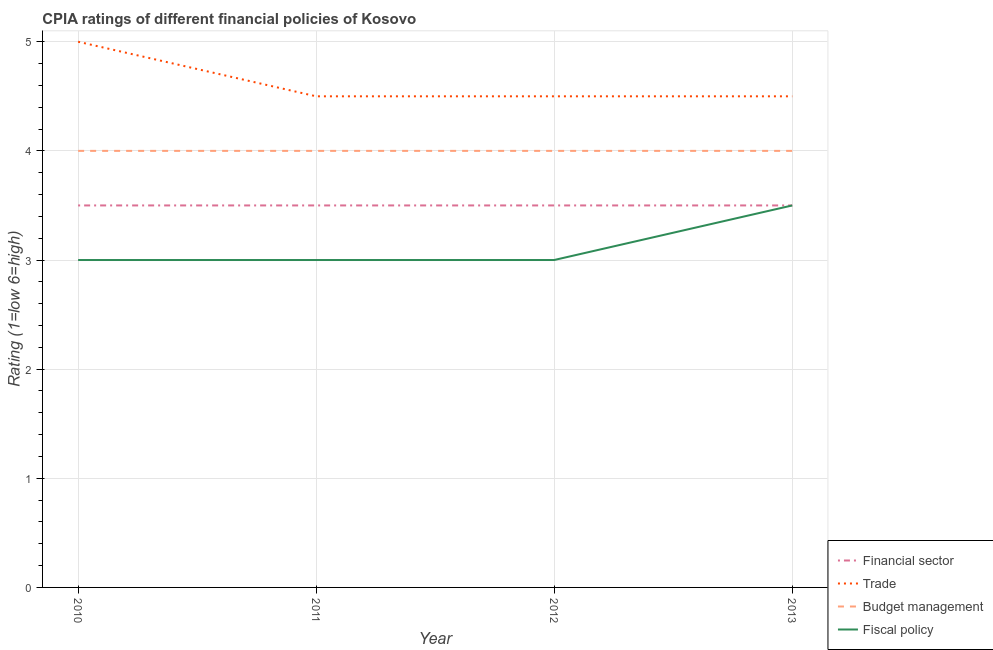Does the line corresponding to cpia rating of budget management intersect with the line corresponding to cpia rating of fiscal policy?
Keep it short and to the point. No. Is the number of lines equal to the number of legend labels?
Give a very brief answer. Yes. Across all years, what is the maximum cpia rating of trade?
Your response must be concise. 5. What is the total cpia rating of fiscal policy in the graph?
Offer a very short reply. 12.5. What is the average cpia rating of financial sector per year?
Provide a short and direct response. 3.5. In how many years, is the cpia rating of trade greater than 2.2?
Ensure brevity in your answer.  4. What is the ratio of the cpia rating of financial sector in 2010 to that in 2011?
Keep it short and to the point. 1. What is the difference between the highest and the second highest cpia rating of fiscal policy?
Your answer should be very brief. 0.5. What is the difference between the highest and the lowest cpia rating of financial sector?
Your answer should be very brief. 0. In how many years, is the cpia rating of trade greater than the average cpia rating of trade taken over all years?
Offer a terse response. 1. Is the sum of the cpia rating of financial sector in 2012 and 2013 greater than the maximum cpia rating of trade across all years?
Provide a short and direct response. Yes. Is it the case that in every year, the sum of the cpia rating of financial sector and cpia rating of trade is greater than the cpia rating of budget management?
Keep it short and to the point. Yes. Does the cpia rating of budget management monotonically increase over the years?
Your response must be concise. No. Is the cpia rating of financial sector strictly greater than the cpia rating of budget management over the years?
Make the answer very short. No. Is the cpia rating of budget management strictly less than the cpia rating of fiscal policy over the years?
Provide a succinct answer. No. How many lines are there?
Your answer should be compact. 4. Are the values on the major ticks of Y-axis written in scientific E-notation?
Your answer should be compact. No. Does the graph contain any zero values?
Make the answer very short. No. Does the graph contain grids?
Offer a terse response. Yes. How many legend labels are there?
Your answer should be compact. 4. What is the title of the graph?
Provide a succinct answer. CPIA ratings of different financial policies of Kosovo. Does "Oil" appear as one of the legend labels in the graph?
Your answer should be very brief. No. What is the label or title of the X-axis?
Ensure brevity in your answer.  Year. What is the label or title of the Y-axis?
Make the answer very short. Rating (1=low 6=high). What is the Rating (1=low 6=high) of Financial sector in 2010?
Keep it short and to the point. 3.5. What is the Rating (1=low 6=high) of Fiscal policy in 2011?
Your answer should be very brief. 3. What is the Rating (1=low 6=high) of Financial sector in 2012?
Keep it short and to the point. 3.5. What is the Rating (1=low 6=high) in Trade in 2012?
Ensure brevity in your answer.  4.5. What is the Rating (1=low 6=high) in Budget management in 2012?
Your response must be concise. 4. What is the Rating (1=low 6=high) of Fiscal policy in 2012?
Offer a very short reply. 3. What is the Rating (1=low 6=high) in Fiscal policy in 2013?
Give a very brief answer. 3.5. Across all years, what is the maximum Rating (1=low 6=high) in Budget management?
Ensure brevity in your answer.  4. Across all years, what is the minimum Rating (1=low 6=high) of Financial sector?
Provide a succinct answer. 3.5. Across all years, what is the minimum Rating (1=low 6=high) of Trade?
Keep it short and to the point. 4.5. Across all years, what is the minimum Rating (1=low 6=high) of Fiscal policy?
Keep it short and to the point. 3. What is the difference between the Rating (1=low 6=high) of Financial sector in 2010 and that in 2011?
Offer a terse response. 0. What is the difference between the Rating (1=low 6=high) in Trade in 2010 and that in 2011?
Offer a very short reply. 0.5. What is the difference between the Rating (1=low 6=high) in Budget management in 2010 and that in 2011?
Keep it short and to the point. 0. What is the difference between the Rating (1=low 6=high) of Budget management in 2010 and that in 2012?
Offer a terse response. 0. What is the difference between the Rating (1=low 6=high) of Budget management in 2011 and that in 2012?
Your answer should be compact. 0. What is the difference between the Rating (1=low 6=high) in Financial sector in 2011 and that in 2013?
Provide a succinct answer. 0. What is the difference between the Rating (1=low 6=high) of Trade in 2011 and that in 2013?
Provide a short and direct response. 0. What is the difference between the Rating (1=low 6=high) in Fiscal policy in 2011 and that in 2013?
Keep it short and to the point. -0.5. What is the difference between the Rating (1=low 6=high) of Trade in 2012 and that in 2013?
Provide a succinct answer. 0. What is the difference between the Rating (1=low 6=high) of Budget management in 2012 and that in 2013?
Keep it short and to the point. 0. What is the difference between the Rating (1=low 6=high) in Fiscal policy in 2012 and that in 2013?
Provide a short and direct response. -0.5. What is the difference between the Rating (1=low 6=high) in Financial sector in 2010 and the Rating (1=low 6=high) in Trade in 2011?
Ensure brevity in your answer.  -1. What is the difference between the Rating (1=low 6=high) of Financial sector in 2010 and the Rating (1=low 6=high) of Budget management in 2011?
Your response must be concise. -0.5. What is the difference between the Rating (1=low 6=high) in Trade in 2010 and the Rating (1=low 6=high) in Budget management in 2011?
Offer a terse response. 1. What is the difference between the Rating (1=low 6=high) of Trade in 2010 and the Rating (1=low 6=high) of Fiscal policy in 2011?
Your response must be concise. 2. What is the difference between the Rating (1=low 6=high) of Budget management in 2010 and the Rating (1=low 6=high) of Fiscal policy in 2012?
Your response must be concise. 1. What is the difference between the Rating (1=low 6=high) in Financial sector in 2010 and the Rating (1=low 6=high) in Trade in 2013?
Your answer should be very brief. -1. What is the difference between the Rating (1=low 6=high) in Financial sector in 2010 and the Rating (1=low 6=high) in Budget management in 2013?
Provide a succinct answer. -0.5. What is the difference between the Rating (1=low 6=high) of Budget management in 2010 and the Rating (1=low 6=high) of Fiscal policy in 2013?
Provide a succinct answer. 0.5. What is the difference between the Rating (1=low 6=high) of Financial sector in 2011 and the Rating (1=low 6=high) of Trade in 2012?
Offer a very short reply. -1. What is the difference between the Rating (1=low 6=high) of Trade in 2011 and the Rating (1=low 6=high) of Fiscal policy in 2012?
Provide a succinct answer. 1.5. What is the difference between the Rating (1=low 6=high) of Budget management in 2011 and the Rating (1=low 6=high) of Fiscal policy in 2012?
Your answer should be very brief. 1. What is the difference between the Rating (1=low 6=high) of Trade in 2011 and the Rating (1=low 6=high) of Fiscal policy in 2013?
Your answer should be compact. 1. What is the difference between the Rating (1=low 6=high) of Financial sector in 2012 and the Rating (1=low 6=high) of Budget management in 2013?
Ensure brevity in your answer.  -0.5. What is the difference between the Rating (1=low 6=high) of Financial sector in 2012 and the Rating (1=low 6=high) of Fiscal policy in 2013?
Give a very brief answer. 0. What is the average Rating (1=low 6=high) of Financial sector per year?
Give a very brief answer. 3.5. What is the average Rating (1=low 6=high) in Trade per year?
Offer a terse response. 4.62. What is the average Rating (1=low 6=high) of Budget management per year?
Provide a short and direct response. 4. What is the average Rating (1=low 6=high) of Fiscal policy per year?
Offer a terse response. 3.12. In the year 2010, what is the difference between the Rating (1=low 6=high) in Financial sector and Rating (1=low 6=high) in Trade?
Offer a terse response. -1.5. In the year 2010, what is the difference between the Rating (1=low 6=high) in Financial sector and Rating (1=low 6=high) in Budget management?
Ensure brevity in your answer.  -0.5. In the year 2011, what is the difference between the Rating (1=low 6=high) of Financial sector and Rating (1=low 6=high) of Fiscal policy?
Your answer should be very brief. 0.5. In the year 2012, what is the difference between the Rating (1=low 6=high) of Financial sector and Rating (1=low 6=high) of Budget management?
Your answer should be very brief. -0.5. In the year 2012, what is the difference between the Rating (1=low 6=high) of Financial sector and Rating (1=low 6=high) of Fiscal policy?
Ensure brevity in your answer.  0.5. In the year 2012, what is the difference between the Rating (1=low 6=high) of Trade and Rating (1=low 6=high) of Budget management?
Provide a succinct answer. 0.5. In the year 2012, what is the difference between the Rating (1=low 6=high) in Trade and Rating (1=low 6=high) in Fiscal policy?
Provide a short and direct response. 1.5. In the year 2012, what is the difference between the Rating (1=low 6=high) of Budget management and Rating (1=low 6=high) of Fiscal policy?
Offer a terse response. 1. In the year 2013, what is the difference between the Rating (1=low 6=high) of Financial sector and Rating (1=low 6=high) of Trade?
Provide a succinct answer. -1. In the year 2013, what is the difference between the Rating (1=low 6=high) of Financial sector and Rating (1=low 6=high) of Budget management?
Offer a very short reply. -0.5. In the year 2013, what is the difference between the Rating (1=low 6=high) of Financial sector and Rating (1=low 6=high) of Fiscal policy?
Give a very brief answer. 0. In the year 2013, what is the difference between the Rating (1=low 6=high) of Trade and Rating (1=low 6=high) of Budget management?
Offer a very short reply. 0.5. In the year 2013, what is the difference between the Rating (1=low 6=high) in Trade and Rating (1=low 6=high) in Fiscal policy?
Your answer should be very brief. 1. What is the ratio of the Rating (1=low 6=high) in Fiscal policy in 2010 to that in 2011?
Keep it short and to the point. 1. What is the ratio of the Rating (1=low 6=high) in Financial sector in 2010 to that in 2012?
Provide a succinct answer. 1. What is the ratio of the Rating (1=low 6=high) in Trade in 2010 to that in 2013?
Make the answer very short. 1.11. What is the ratio of the Rating (1=low 6=high) in Budget management in 2010 to that in 2013?
Provide a succinct answer. 1. What is the ratio of the Rating (1=low 6=high) in Trade in 2011 to that in 2012?
Provide a short and direct response. 1. What is the ratio of the Rating (1=low 6=high) of Fiscal policy in 2011 to that in 2012?
Offer a very short reply. 1. What is the ratio of the Rating (1=low 6=high) of Trade in 2011 to that in 2013?
Your response must be concise. 1. What is the ratio of the Rating (1=low 6=high) in Financial sector in 2012 to that in 2013?
Offer a terse response. 1. What is the ratio of the Rating (1=low 6=high) of Budget management in 2012 to that in 2013?
Ensure brevity in your answer.  1. What is the ratio of the Rating (1=low 6=high) in Fiscal policy in 2012 to that in 2013?
Your answer should be very brief. 0.86. What is the difference between the highest and the second highest Rating (1=low 6=high) in Financial sector?
Your answer should be compact. 0. What is the difference between the highest and the second highest Rating (1=low 6=high) of Budget management?
Your answer should be very brief. 0. What is the difference between the highest and the second highest Rating (1=low 6=high) of Fiscal policy?
Offer a terse response. 0.5. What is the difference between the highest and the lowest Rating (1=low 6=high) of Financial sector?
Your answer should be compact. 0. What is the difference between the highest and the lowest Rating (1=low 6=high) in Budget management?
Provide a short and direct response. 0. What is the difference between the highest and the lowest Rating (1=low 6=high) in Fiscal policy?
Provide a succinct answer. 0.5. 